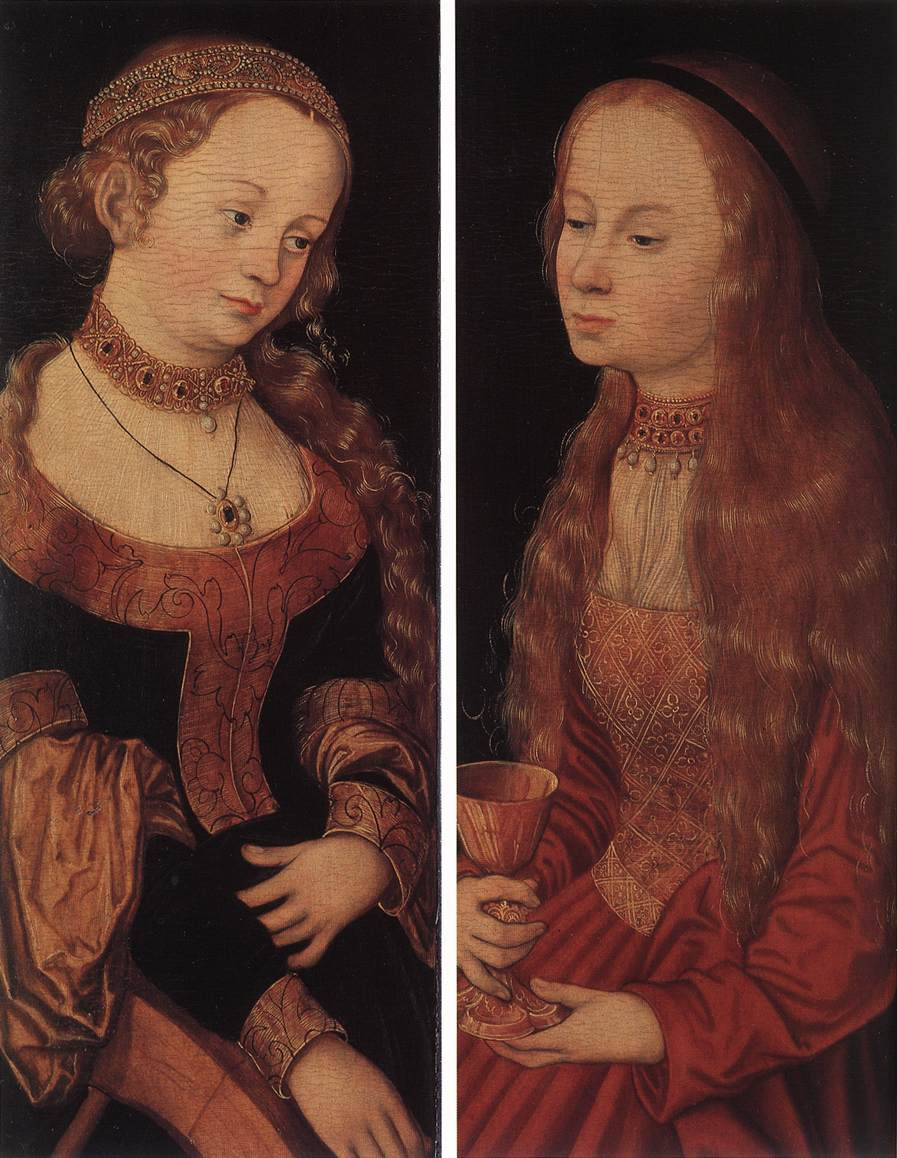What's happening in the scene? The image is a diptych oil painting from the Northern Renaissance, showcasing two separate yet harmonious panels. Each panel features a young woman dressed in elegant, richly detailed clothing, set against a dark, plain background which highlights their presence.

In the left panel, a blonde woman is depicted wearing an intricately embroidered red dress. Her gold and pearl headdress contributes to her noble appearance. She holds a book, symbolizing knowledge and wisdom, and a flower, which often represents beauty and nature.

The right panel depicts another young woman with red hair, also dressed in a red gown adorned with gold embroidery. Her black headdress contrasts strikingly with her fiery hair. She holds a cup, a symbol typically associated with receptivity and abundance, adding another layer to the symbolic narrative of the painting.

This artwork is a fine example of the meticulous craftsmanship and symbolic storytelling that characterizes the Northern Renaissance, reflecting its cultural values and artistic strategies. 